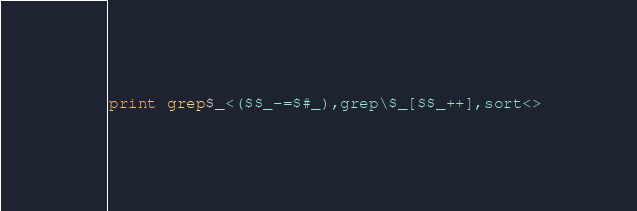Convert code to text. <code><loc_0><loc_0><loc_500><loc_500><_Perl_>print grep$_<($$_-=$#_),grep\$_[$$_++],sort<></code> 